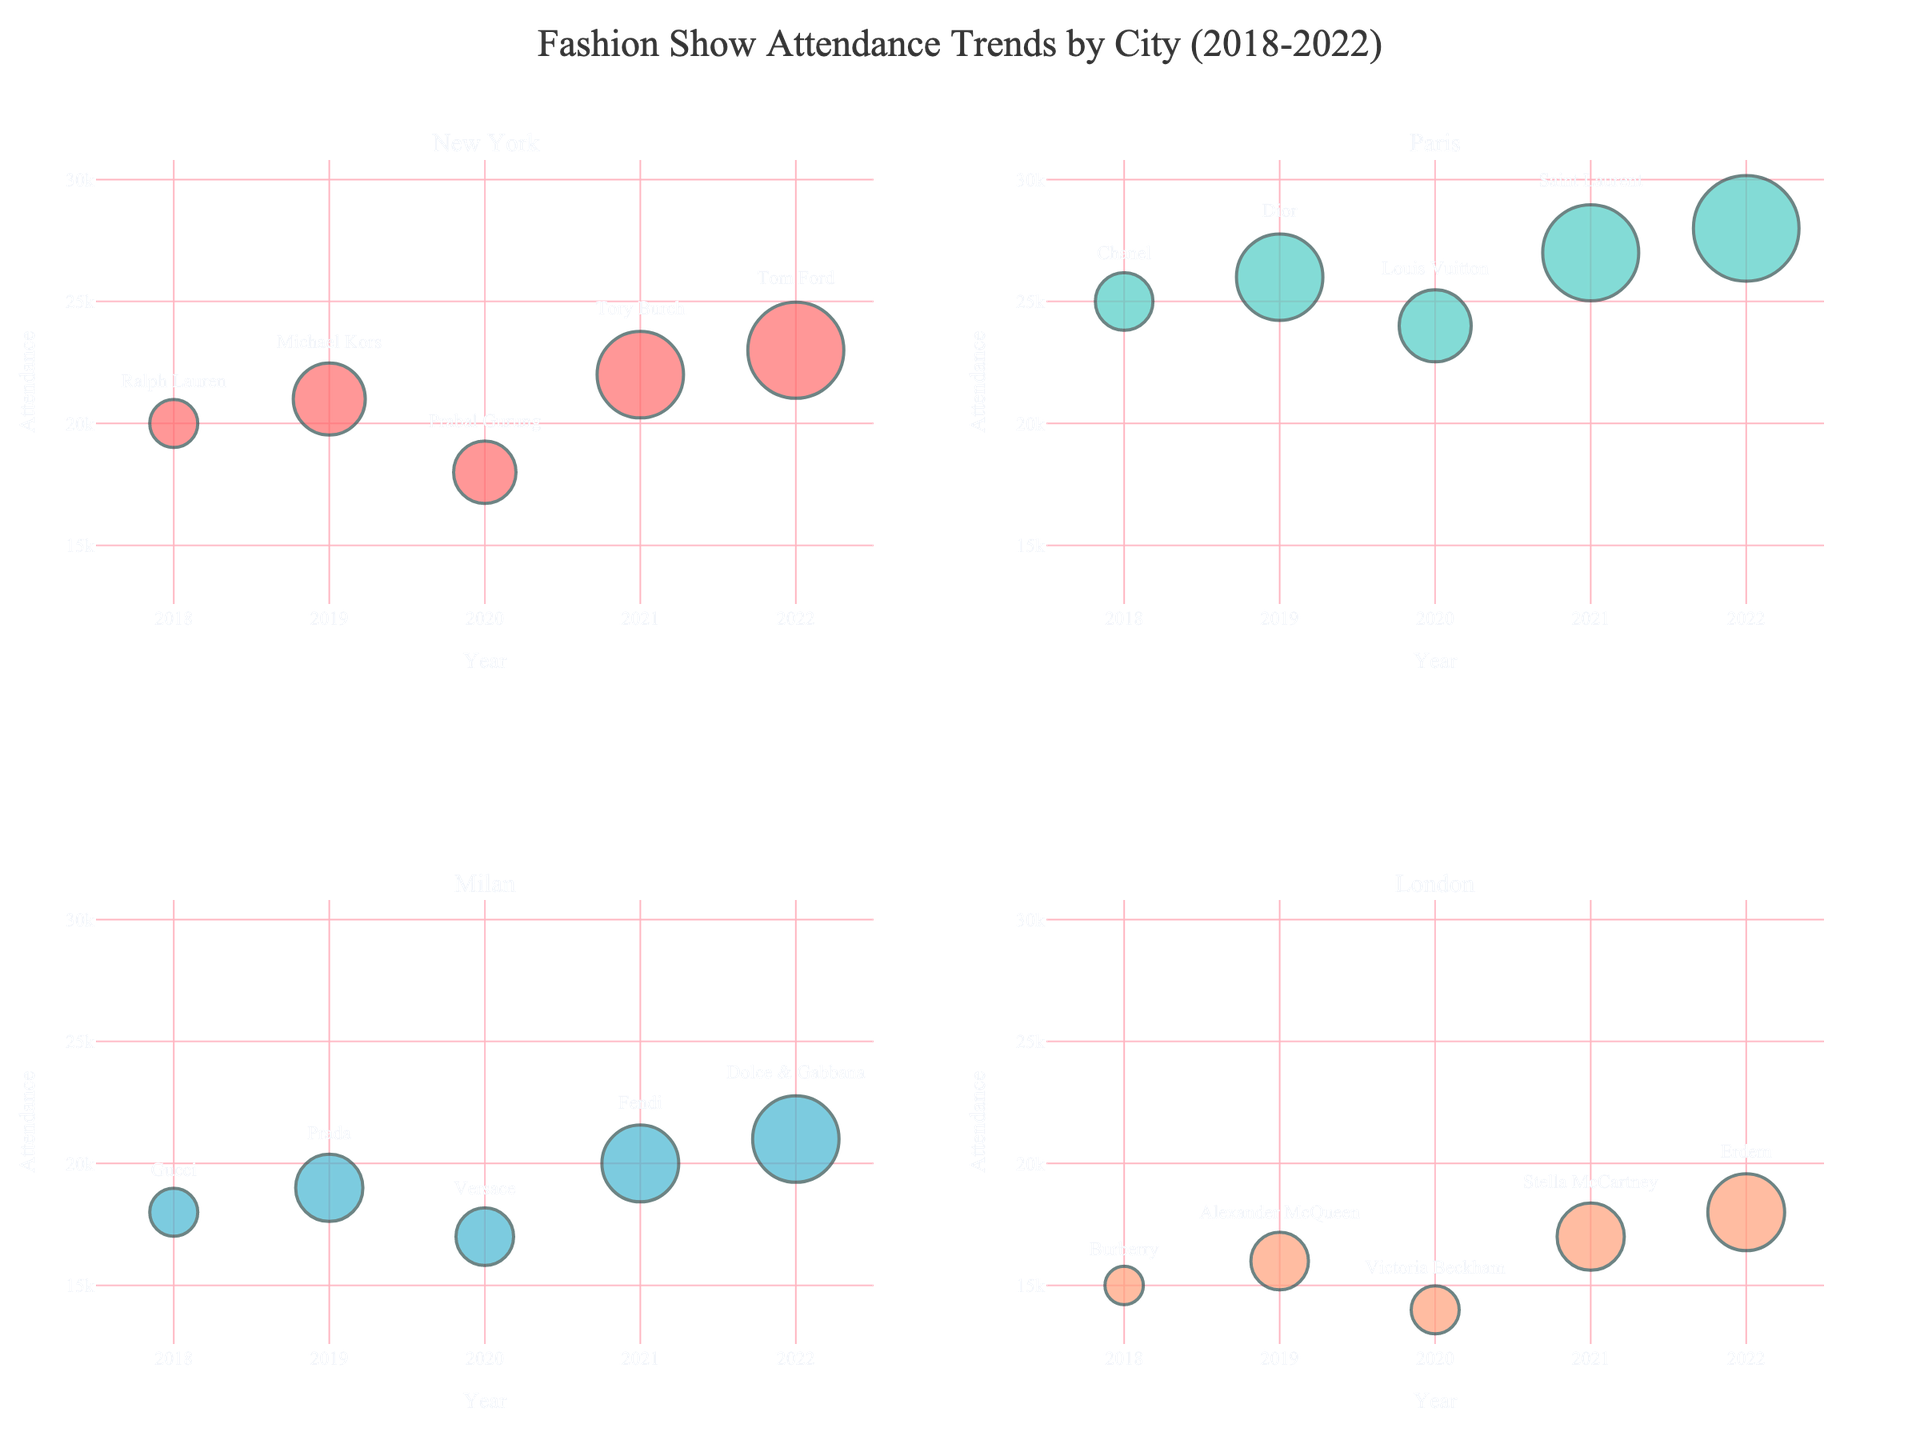What is the title of the subplot figure? The figure's title is usually located at the top center of the plot. For this specific figure, we can see it reads "Fashion Show Attendance Trends by City (2018-2022)".
Answer: Fashion Show Attendance Trends by City (2018-2022) How many data points are displayed for each city? Each bubble represents one data point corresponding to a year, and each city has five years of data points from 2018 to 2022.
Answer: 5 Which city had the highest fashion show attendance in 2022? By looking at the y-axis values for each city's subplot in 2022, the bubble for Paris in 2022 has the highest y-axis value.
Answer: Paris What was the attendance at the Ralph Lauren show in New York in 2018? The hover text will show the attendance details. Hovering over the bubble for New York in 2018, you can see the attendance was 20,000.
Answer: 20,000 What is the overall attendance trend for London from 2018 to 2022? Observing the progression of y-axis values for London from 2018 to 2022 shows a generally increasing trend in attendance.
Answer: Increasing Compare the attendance of Chanel's show in Paris in 2018 to that of Burberry's show in London in 2018. Which one had more attendees? From the subplot for Paris, the Chanel show in 2018 had an attendance of 25,000. From the subplot for London, Burberry's show in 2018 had an attendance of 15,000.
Answer: Chanel's show Which year had the lowest attendance in Milan and what was the attendance figure? By looking at the y-axis values for the Milan bubbles, the year 2020 shows the lowest attendance at 17,000.
Answer: 2020; 17,000 What is the average attendance for New York shows over the given years? Add the attendance figures for New York (20,000 + 21,000 + 18,000 + 22,000 + 23,000) and divide by the number of data points (5). (20,000 + 21,000 + 18,000 + 22,000 + 23,000) / 5 = 20,800.
Answer: 20,800 In which city did Louis Vuitton have a highlighted show, and in what year? The hover text reveals that Louis Vuitton's show was in Paris in 2020.
Answer: Paris, 2020 